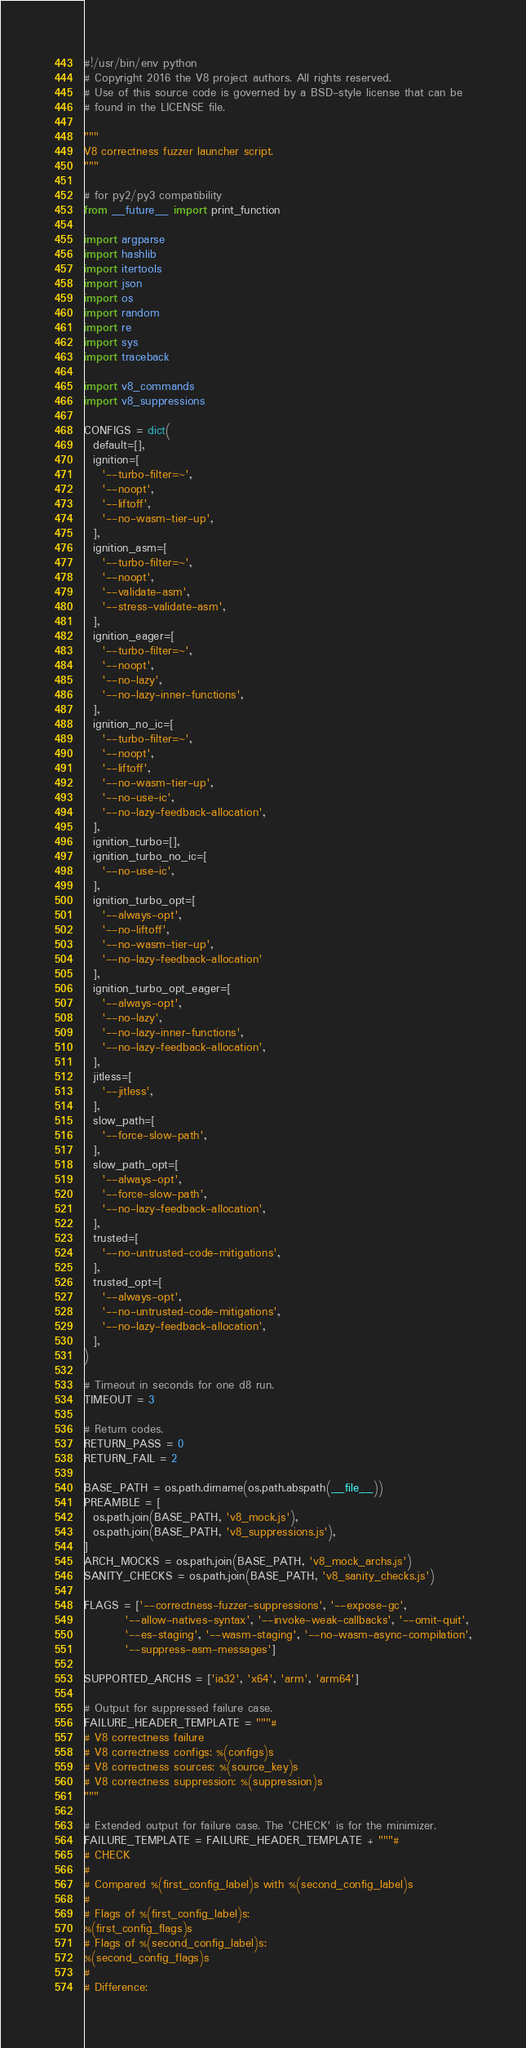Convert code to text. <code><loc_0><loc_0><loc_500><loc_500><_Python_>#!/usr/bin/env python
# Copyright 2016 the V8 project authors. All rights reserved.
# Use of this source code is governed by a BSD-style license that can be
# found in the LICENSE file.

"""
V8 correctness fuzzer launcher script.
"""

# for py2/py3 compatibility
from __future__ import print_function

import argparse
import hashlib
import itertools
import json
import os
import random
import re
import sys
import traceback

import v8_commands
import v8_suppressions

CONFIGS = dict(
  default=[],
  ignition=[
    '--turbo-filter=~',
    '--noopt',
    '--liftoff',
    '--no-wasm-tier-up',
  ],
  ignition_asm=[
    '--turbo-filter=~',
    '--noopt',
    '--validate-asm',
    '--stress-validate-asm',
  ],
  ignition_eager=[
    '--turbo-filter=~',
    '--noopt',
    '--no-lazy',
    '--no-lazy-inner-functions',
  ],
  ignition_no_ic=[
    '--turbo-filter=~',
    '--noopt',
    '--liftoff',
    '--no-wasm-tier-up',
    '--no-use-ic',
    '--no-lazy-feedback-allocation',
  ],
  ignition_turbo=[],
  ignition_turbo_no_ic=[
    '--no-use-ic',
  ],
  ignition_turbo_opt=[
    '--always-opt',
    '--no-liftoff',
    '--no-wasm-tier-up',
    '--no-lazy-feedback-allocation'
  ],
  ignition_turbo_opt_eager=[
    '--always-opt',
    '--no-lazy',
    '--no-lazy-inner-functions',
    '--no-lazy-feedback-allocation',
  ],
  jitless=[
    '--jitless',
  ],
  slow_path=[
    '--force-slow-path',
  ],
  slow_path_opt=[
    '--always-opt',
    '--force-slow-path',
    '--no-lazy-feedback-allocation',
  ],
  trusted=[
    '--no-untrusted-code-mitigations',
  ],
  trusted_opt=[
    '--always-opt',
    '--no-untrusted-code-mitigations',
    '--no-lazy-feedback-allocation',
  ],
)

# Timeout in seconds for one d8 run.
TIMEOUT = 3

# Return codes.
RETURN_PASS = 0
RETURN_FAIL = 2

BASE_PATH = os.path.dirname(os.path.abspath(__file__))
PREAMBLE = [
  os.path.join(BASE_PATH, 'v8_mock.js'),
  os.path.join(BASE_PATH, 'v8_suppressions.js'),
]
ARCH_MOCKS = os.path.join(BASE_PATH, 'v8_mock_archs.js')
SANITY_CHECKS = os.path.join(BASE_PATH, 'v8_sanity_checks.js')

FLAGS = ['--correctness-fuzzer-suppressions', '--expose-gc',
         '--allow-natives-syntax', '--invoke-weak-callbacks', '--omit-quit',
         '--es-staging', '--wasm-staging', '--no-wasm-async-compilation',
         '--suppress-asm-messages']

SUPPORTED_ARCHS = ['ia32', 'x64', 'arm', 'arm64']

# Output for suppressed failure case.
FAILURE_HEADER_TEMPLATE = """#
# V8 correctness failure
# V8 correctness configs: %(configs)s
# V8 correctness sources: %(source_key)s
# V8 correctness suppression: %(suppression)s
"""

# Extended output for failure case. The 'CHECK' is for the minimizer.
FAILURE_TEMPLATE = FAILURE_HEADER_TEMPLATE + """#
# CHECK
#
# Compared %(first_config_label)s with %(second_config_label)s
#
# Flags of %(first_config_label)s:
%(first_config_flags)s
# Flags of %(second_config_label)s:
%(second_config_flags)s
#
# Difference:</code> 